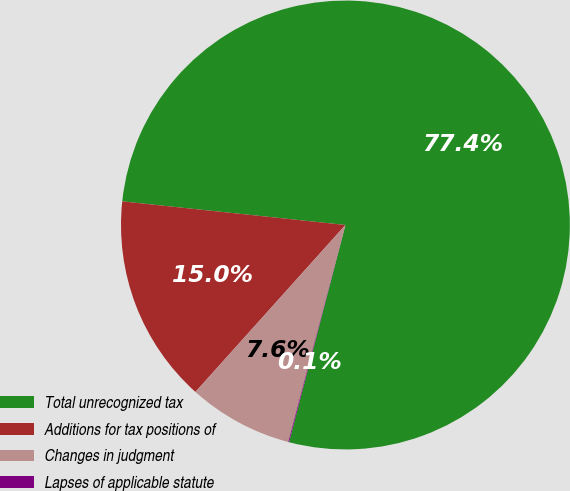<chart> <loc_0><loc_0><loc_500><loc_500><pie_chart><fcel>Total unrecognized tax<fcel>Additions for tax positions of<fcel>Changes in judgment<fcel>Lapses of applicable statute<nl><fcel>77.36%<fcel>15.03%<fcel>7.55%<fcel>0.06%<nl></chart> 